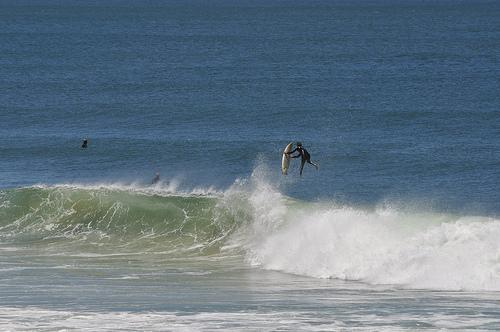Summarize the main action happening in the picture and the key figure involved. A daring surfer displays his skills by leaping into the air with his white surfboard amidst powerful waves. Mention the most important element in the image and describe its activity. A surfer is in mid-air with a white surfboard, performing an impressive aerial maneuver above a large wave. Describe the prominent subject in the photo and their connection with the setting. A person in a wetsuit grips his surfboard as he catches air above the tumultuous ocean waves. Mention the main individual in the image and provide context about their actions. A surfer clings to a white surfboard as he stylishly sails through the air amidst an intense oceanic backdrop. Briefly mention the critical event in the image and its central participant. A surfer achieves a stunning aerial feat, leaping above the ocean's undulating waves with his white surfboard. Describe the main subject in the image and how they interact with their surroundings. A person wearing a wetsuit expertly navigates the ocean's challenging waves, flying through the air with his surfboard in tow. Tell about the focal point in the image and the environment it is in. A man wearing a wetsuit jumps high into the air with his surfboard, surrounded by the fierce beauty of the ocean's waves. Write a brief statement focusing on the central figure in the image and their actions. A wetsuit-clad man clutches his surfboard, soaring above crashing waves with acrobatic agility. Highlight the primary object in the image and its surroundings. A man holding a surfboard is suspended in mid-air amidst an ocean scene of frothy waves and sea foam. Explain the pivotal moment captured in the picture and its relationship to the environment. An athletic person in a wetsuit launches into the air with a white surfboard, highlighting their skill against the ocean's powerful waves. 